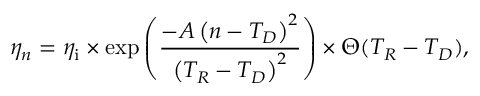Convert formula to latex. <formula><loc_0><loc_0><loc_500><loc_500>\eta _ { n } = \eta _ { i } \times \exp \left ( \frac { - A \left ( n - T _ { D } \right ) ^ { 2 } } { \left ( T _ { R } - T _ { D } \right ) ^ { 2 } } \right ) \times \Theta ( T _ { R } - T _ { D } ) ,</formula> 